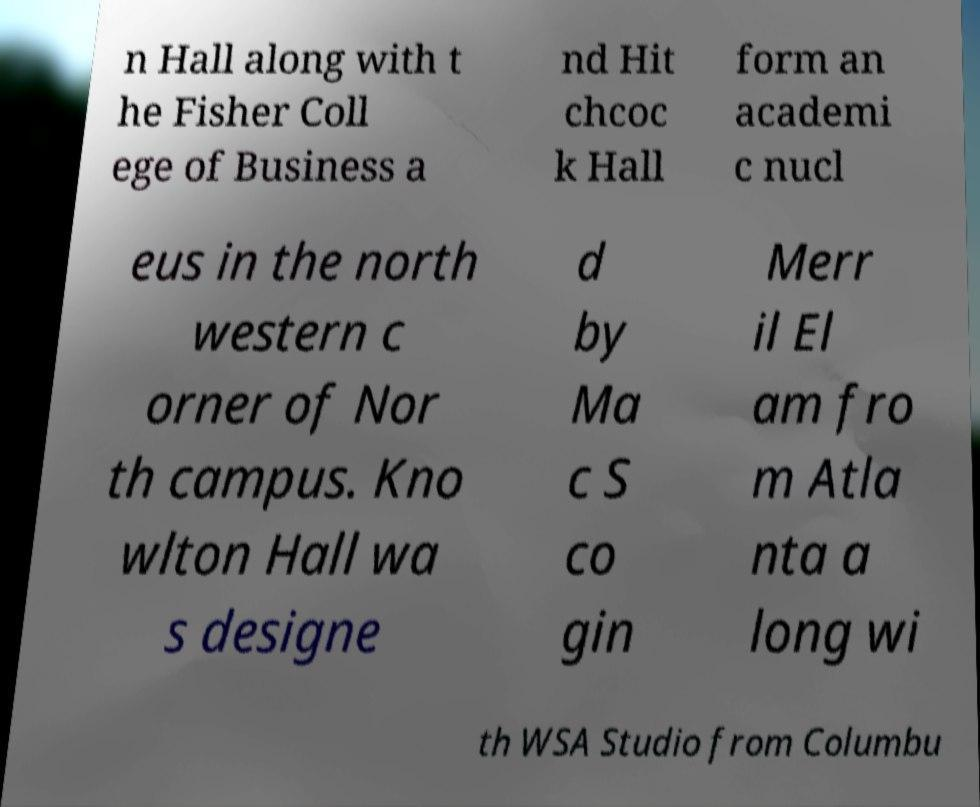I need the written content from this picture converted into text. Can you do that? n Hall along with t he Fisher Coll ege of Business a nd Hit chcoc k Hall form an academi c nucl eus in the north western c orner of Nor th campus. Kno wlton Hall wa s designe d by Ma c S co gin Merr il El am fro m Atla nta a long wi th WSA Studio from Columbu 